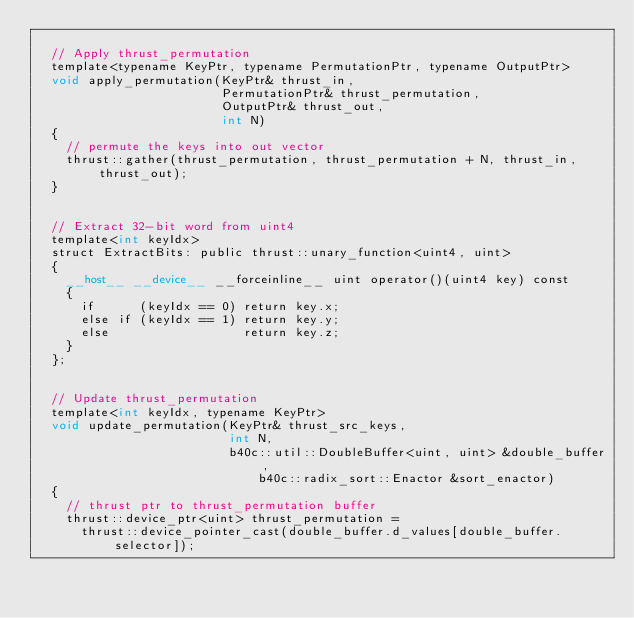<code> <loc_0><loc_0><loc_500><loc_500><_Cuda_>
  // Apply thrust_permutation
  template<typename KeyPtr, typename PermutationPtr, typename OutputPtr>
  void apply_permutation(KeyPtr& thrust_in,
                         PermutationPtr& thrust_permutation,
                         OutputPtr& thrust_out,
                         int N)
  {
    // permute the keys into out vector
    thrust::gather(thrust_permutation, thrust_permutation + N, thrust_in, thrust_out);
  }


  // Extract 32-bit word from uint4
  template<int keyIdx>
  struct ExtractBits: public thrust::unary_function<uint4, uint>
  {
    __host__ __device__ __forceinline__ uint operator()(uint4 key) const
    {
      if      (keyIdx == 0) return key.x;
      else if (keyIdx == 1) return key.y;
      else                  return key.z;
    }
  };


  // Update thrust_permutation
  template<int keyIdx, typename KeyPtr>
  void update_permutation(KeyPtr& thrust_src_keys, 
                          int N,
                          b40c::util::DoubleBuffer<uint, uint> &double_buffer,
		                      b40c::radix_sort::Enactor &sort_enactor)
  {
    // thrust ptr to thrust_permutation buffer
    thrust::device_ptr<uint> thrust_permutation = 
      thrust::device_pointer_cast(double_buffer.d_values[double_buffer.selector]);
</code> 